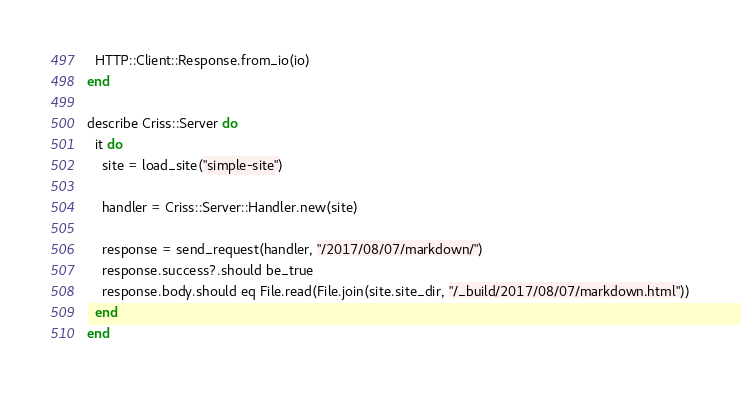<code> <loc_0><loc_0><loc_500><loc_500><_Crystal_>  HTTP::Client::Response.from_io(io)
end

describe Criss::Server do
  it do
    site = load_site("simple-site")

    handler = Criss::Server::Handler.new(site)

    response = send_request(handler, "/2017/08/07/markdown/")
    response.success?.should be_true
    response.body.should eq File.read(File.join(site.site_dir, "/_build/2017/08/07/markdown.html"))
  end
end
</code> 